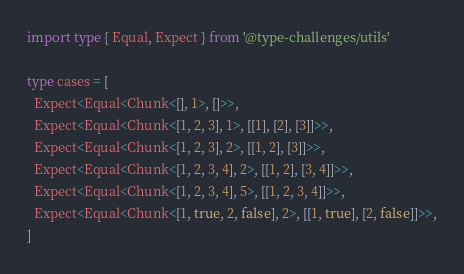<code> <loc_0><loc_0><loc_500><loc_500><_TypeScript_>import type { Equal, Expect } from '@type-challenges/utils'

type cases = [
  Expect<Equal<Chunk<[], 1>, []>>,
  Expect<Equal<Chunk<[1, 2, 3], 1>, [[1], [2], [3]]>>,
  Expect<Equal<Chunk<[1, 2, 3], 2>, [[1, 2], [3]]>>,
  Expect<Equal<Chunk<[1, 2, 3, 4], 2>, [[1, 2], [3, 4]]>>,
  Expect<Equal<Chunk<[1, 2, 3, 4], 5>, [[1, 2, 3, 4]]>>,
  Expect<Equal<Chunk<[1, true, 2, false], 2>, [[1, true], [2, false]]>>,
]
</code> 